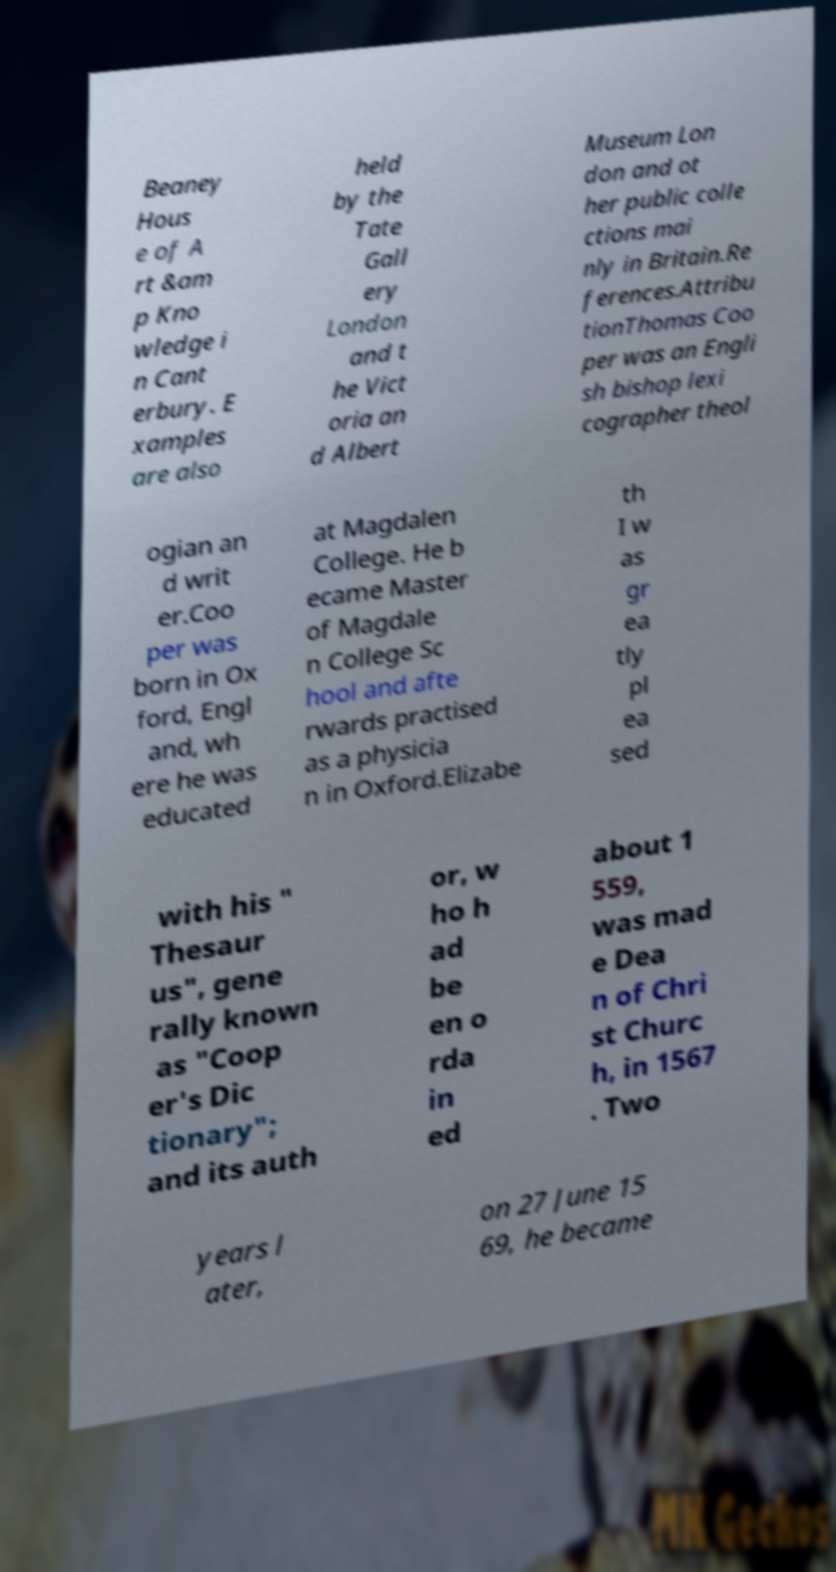For documentation purposes, I need the text within this image transcribed. Could you provide that? Beaney Hous e of A rt &am p Kno wledge i n Cant erbury. E xamples are also held by the Tate Gall ery London and t he Vict oria an d Albert Museum Lon don and ot her public colle ctions mai nly in Britain.Re ferences.Attribu tionThomas Coo per was an Engli sh bishop lexi cographer theol ogian an d writ er.Coo per was born in Ox ford, Engl and, wh ere he was educated at Magdalen College. He b ecame Master of Magdale n College Sc hool and afte rwards practised as a physicia n in Oxford.Elizabe th I w as gr ea tly pl ea sed with his " Thesaur us", gene rally known as "Coop er's Dic tionary"; and its auth or, w ho h ad be en o rda in ed about 1 559, was mad e Dea n of Chri st Churc h, in 1567 . Two years l ater, on 27 June 15 69, he became 